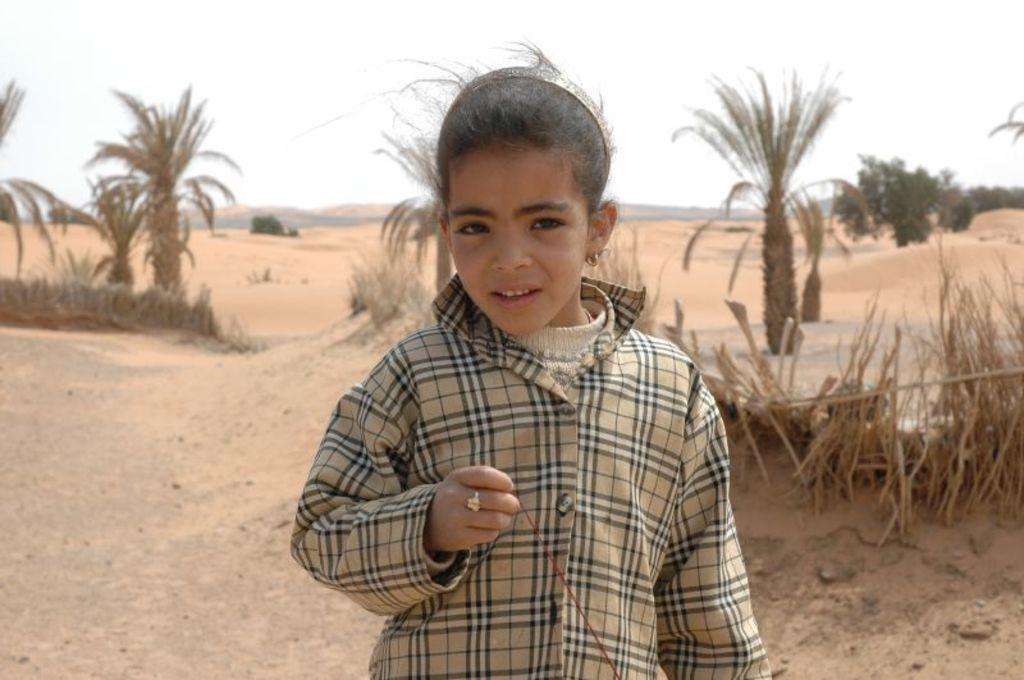What is the main subject of the image? There is a person standing in the image. What is the person wearing? The person is wearing a dress with cream and black colors. What can be seen in the background of the image? There are trees and the sky visible in the background of the image. What is the color of the trees in the image? The trees are green in color. What is the color of the sky in the image? The sky is white in color. Can you tell me how many hens are visible in the image? There are no hens present in the image; it features a person standing in front of green trees and a white sky. What type of instrument is the person playing in the image? There is no instrument present in the image; the person is simply standing and wearing a dress with cream and black colors. 